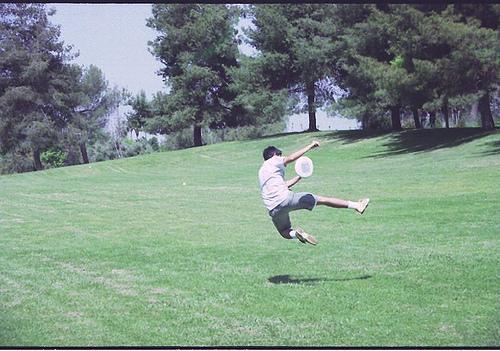How many people are in the photo?
Give a very brief answer. 1. 